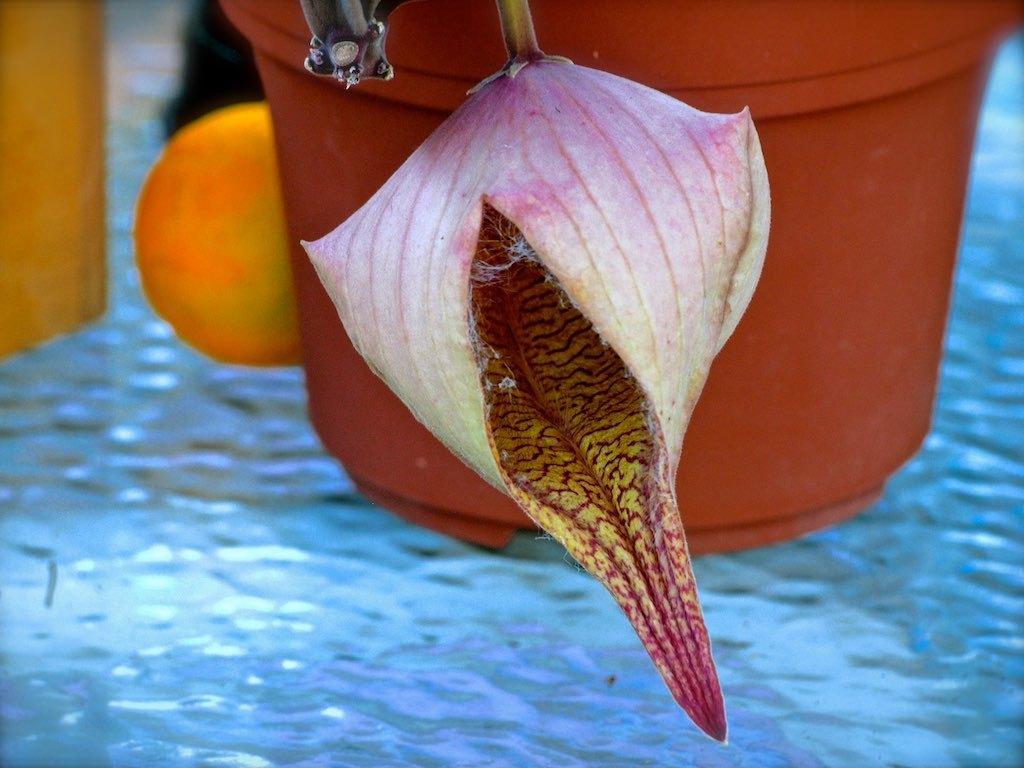Please provide a concise description of this image. In this image I can see water, flower pot, flower bud, stems and objects.   